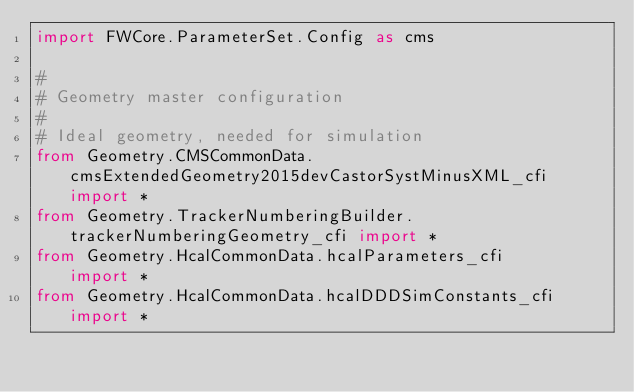Convert code to text. <code><loc_0><loc_0><loc_500><loc_500><_Python_>import FWCore.ParameterSet.Config as cms

#
# Geometry master configuration
#
# Ideal geometry, needed for simulation
from Geometry.CMSCommonData.cmsExtendedGeometry2015devCastorSystMinusXML_cfi import *
from Geometry.TrackerNumberingBuilder.trackerNumberingGeometry_cfi import *
from Geometry.HcalCommonData.hcalParameters_cfi      import *
from Geometry.HcalCommonData.hcalDDDSimConstants_cfi import *

</code> 